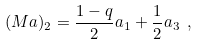<formula> <loc_0><loc_0><loc_500><loc_500>( M a ) _ { 2 } = \frac { 1 - q } { 2 } a _ { 1 } + \frac { 1 } { 2 } a _ { 3 } \ ,</formula> 